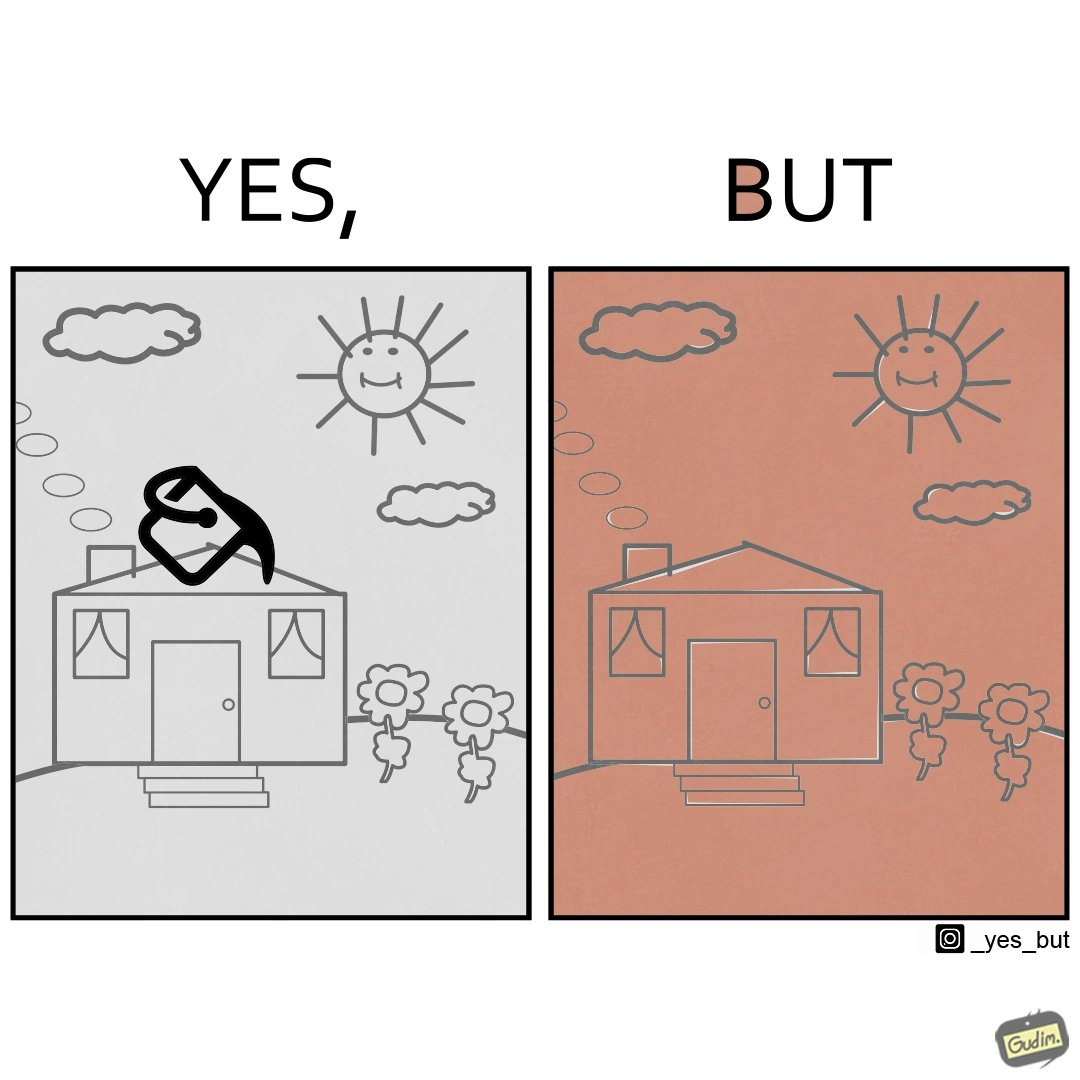Describe what you see in the left and right parts of this image. In the left part of the image: The image shows a drawing made on a windows paint like application. The drawing contains a house with smoke coming out of the chimney, clouds, sun and flowers next to the house. The image also shows fill color option which is indicated by a bucket of paint being used on the ceiling of the house to fill it with a color. In the right part of the image: The image shows a drawing made on a windows paint like application. The drawing contains a house with smoke coming out of the chimney, clouds, sun and flowers next to the house. The entire drawing is colored with brick red color. 